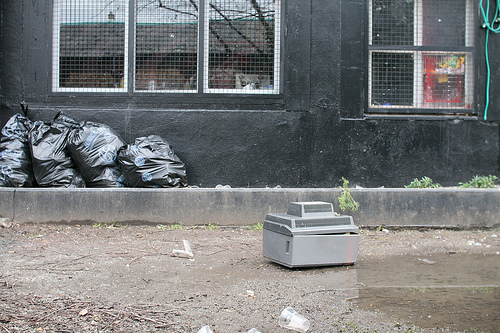<image>
Is there a trash bag in front of the plastic cup? No. The trash bag is not in front of the plastic cup. The spatial positioning shows a different relationship between these objects. 